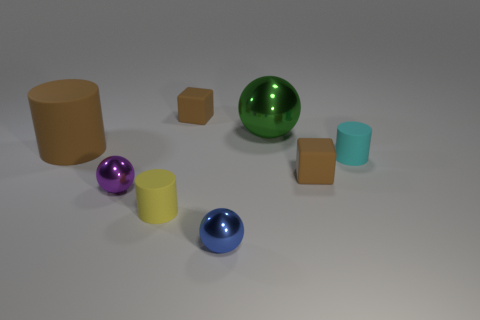How many brown objects are big spheres or tiny rubber things?
Keep it short and to the point. 2. There is a small brown thing that is in front of the green thing; is it the same shape as the small object left of the yellow object?
Your answer should be compact. No. What number of other objects are the same material as the large green ball?
Make the answer very short. 2. Is there a tiny brown thing left of the small purple object in front of the big object that is on the left side of the small purple object?
Your answer should be very brief. No. Is the big cylinder made of the same material as the small cyan cylinder?
Provide a short and direct response. Yes. Are there any other things that have the same shape as the large brown matte object?
Your response must be concise. Yes. There is a tiny cylinder on the right side of the brown matte block on the left side of the small blue thing; what is it made of?
Offer a terse response. Rubber. There is a shiny thing that is left of the tiny blue object; what size is it?
Your response must be concise. Small. What is the color of the small object that is both left of the tiny cyan rubber cylinder and on the right side of the large shiny object?
Provide a succinct answer. Brown. Does the thing left of the purple sphere have the same size as the small yellow rubber thing?
Give a very brief answer. No. 